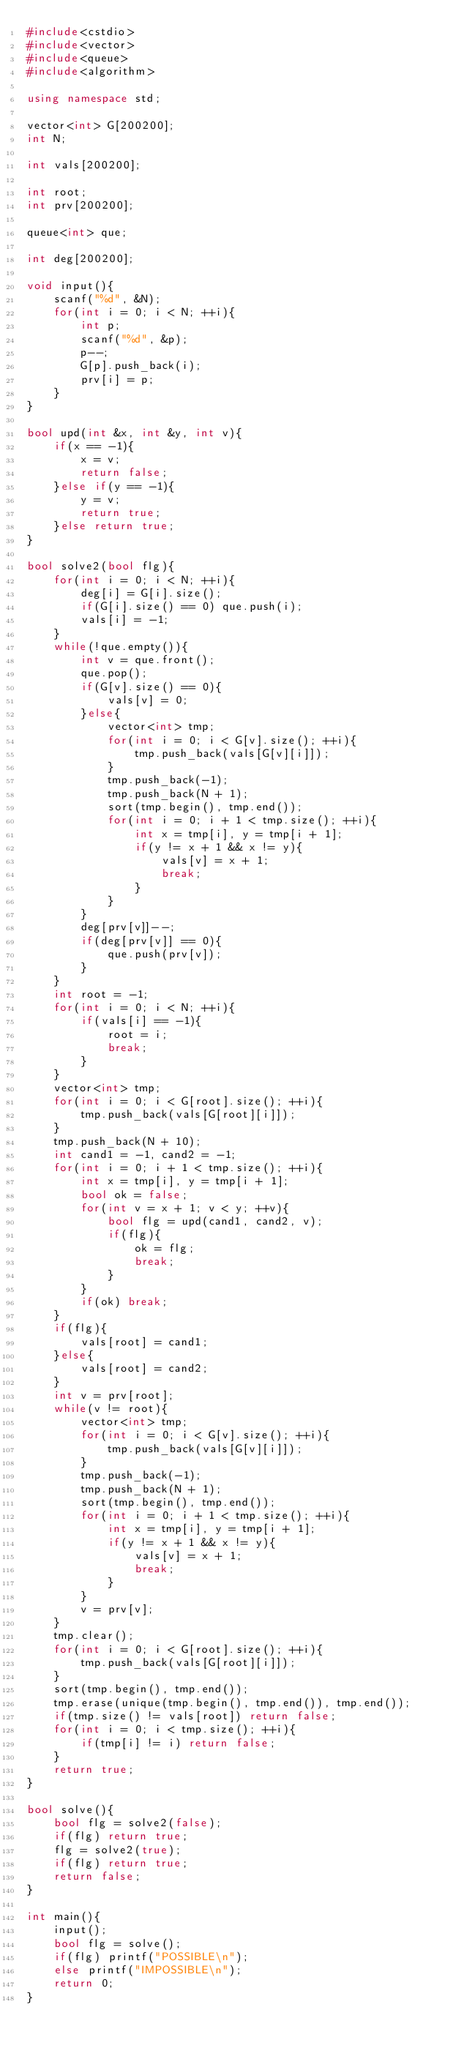Convert code to text. <code><loc_0><loc_0><loc_500><loc_500><_C++_>#include<cstdio>
#include<vector>
#include<queue>
#include<algorithm>

using namespace std;

vector<int> G[200200];
int N;

int vals[200200];

int root;
int prv[200200];

queue<int> que;

int deg[200200];

void input(){
	scanf("%d", &N);
	for(int i = 0; i < N; ++i){
		int p;
		scanf("%d", &p);
		p--;
		G[p].push_back(i);
		prv[i] = p;
	}
}

bool upd(int &x, int &y, int v){
	if(x == -1){
		x = v;
		return false;
	}else if(y == -1){
		y = v;
		return true;
	}else return true;
}

bool solve2(bool flg){
	for(int i = 0; i < N; ++i){
		deg[i] = G[i].size();
		if(G[i].size() == 0) que.push(i);
		vals[i] = -1;
	}
	while(!que.empty()){
		int v = que.front();
		que.pop();
		if(G[v].size() == 0){
			vals[v] = 0;
		}else{
			vector<int> tmp;
			for(int i = 0; i < G[v].size(); ++i){
				tmp.push_back(vals[G[v][i]]);
			}
			tmp.push_back(-1);
			tmp.push_back(N + 1);
			sort(tmp.begin(), tmp.end());
			for(int i = 0; i + 1 < tmp.size(); ++i){
				int x = tmp[i], y = tmp[i + 1];
				if(y != x + 1 && x != y){
					vals[v] = x + 1;
					break;
				}
			}
		}
		deg[prv[v]]--;
		if(deg[prv[v]] == 0){
			que.push(prv[v]);
		}
	}
	int root = -1;
	for(int i = 0; i < N; ++i){
		if(vals[i] == -1){
			root = i;
			break;
		}
	}
	vector<int> tmp;
	for(int i = 0; i < G[root].size(); ++i){
		tmp.push_back(vals[G[root][i]]);
	}
	tmp.push_back(N + 10);
	int cand1 = -1, cand2 = -1;
	for(int i = 0; i + 1 < tmp.size(); ++i){
		int x = tmp[i], y = tmp[i + 1];
		bool ok = false;
		for(int v = x + 1; v < y; ++v){
			bool flg = upd(cand1, cand2, v);
			if(flg){
				ok = flg;
				break;
			}
		}
		if(ok) break;
	}
	if(flg){
		vals[root] = cand1;
	}else{
		vals[root] = cand2;
	}
	int v = prv[root];
	while(v != root){
		vector<int> tmp;
		for(int i = 0; i < G[v].size(); ++i){
			tmp.push_back(vals[G[v][i]]);
		}
		tmp.push_back(-1);
		tmp.push_back(N + 1);
		sort(tmp.begin(), tmp.end());
		for(int i = 0; i + 1 < tmp.size(); ++i){
			int x = tmp[i], y = tmp[i + 1];
			if(y != x + 1 && x != y){
				vals[v] = x + 1;
				break;
			}
		}
		v = prv[v];
	}
	tmp.clear();
	for(int i = 0; i < G[root].size(); ++i){
		tmp.push_back(vals[G[root][i]]);
	}
	sort(tmp.begin(), tmp.end());
	tmp.erase(unique(tmp.begin(), tmp.end()), tmp.end());
	if(tmp.size() != vals[root]) return false;
	for(int i = 0; i < tmp.size(); ++i){
		if(tmp[i] != i) return false;
	}
	return true;
}

bool solve(){
	bool flg = solve2(false);
	if(flg) return true;
	flg = solve2(true);
	if(flg) return true;
	return false;
}

int main(){
	input();
	bool flg = solve();
	if(flg) printf("POSSIBLE\n");
	else printf("IMPOSSIBLE\n");
	return 0;
}
</code> 